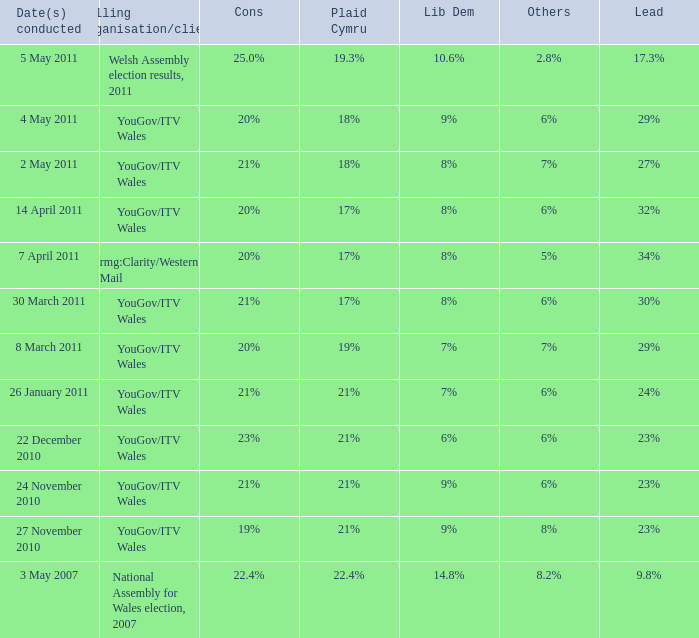I want the plaid cymru for 4 may 2011 18%. 